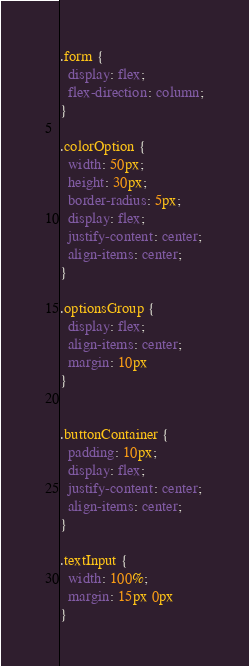Convert code to text. <code><loc_0><loc_0><loc_500><loc_500><_CSS_>.form {
  display: flex;
  flex-direction: column;
}

.colorOption {
  width: 50px;
  height: 30px;
  border-radius: 5px;
  display: flex;
  justify-content: center;
  align-items: center;
}

.optionsGroup {
  display: flex;
  align-items: center;
  margin: 10px
}


.buttonContainer {
  padding: 10px;
  display: flex;
  justify-content: center;
  align-items: center;
}

.textInput {
  width: 100%;
  margin: 15px 0px
}</code> 